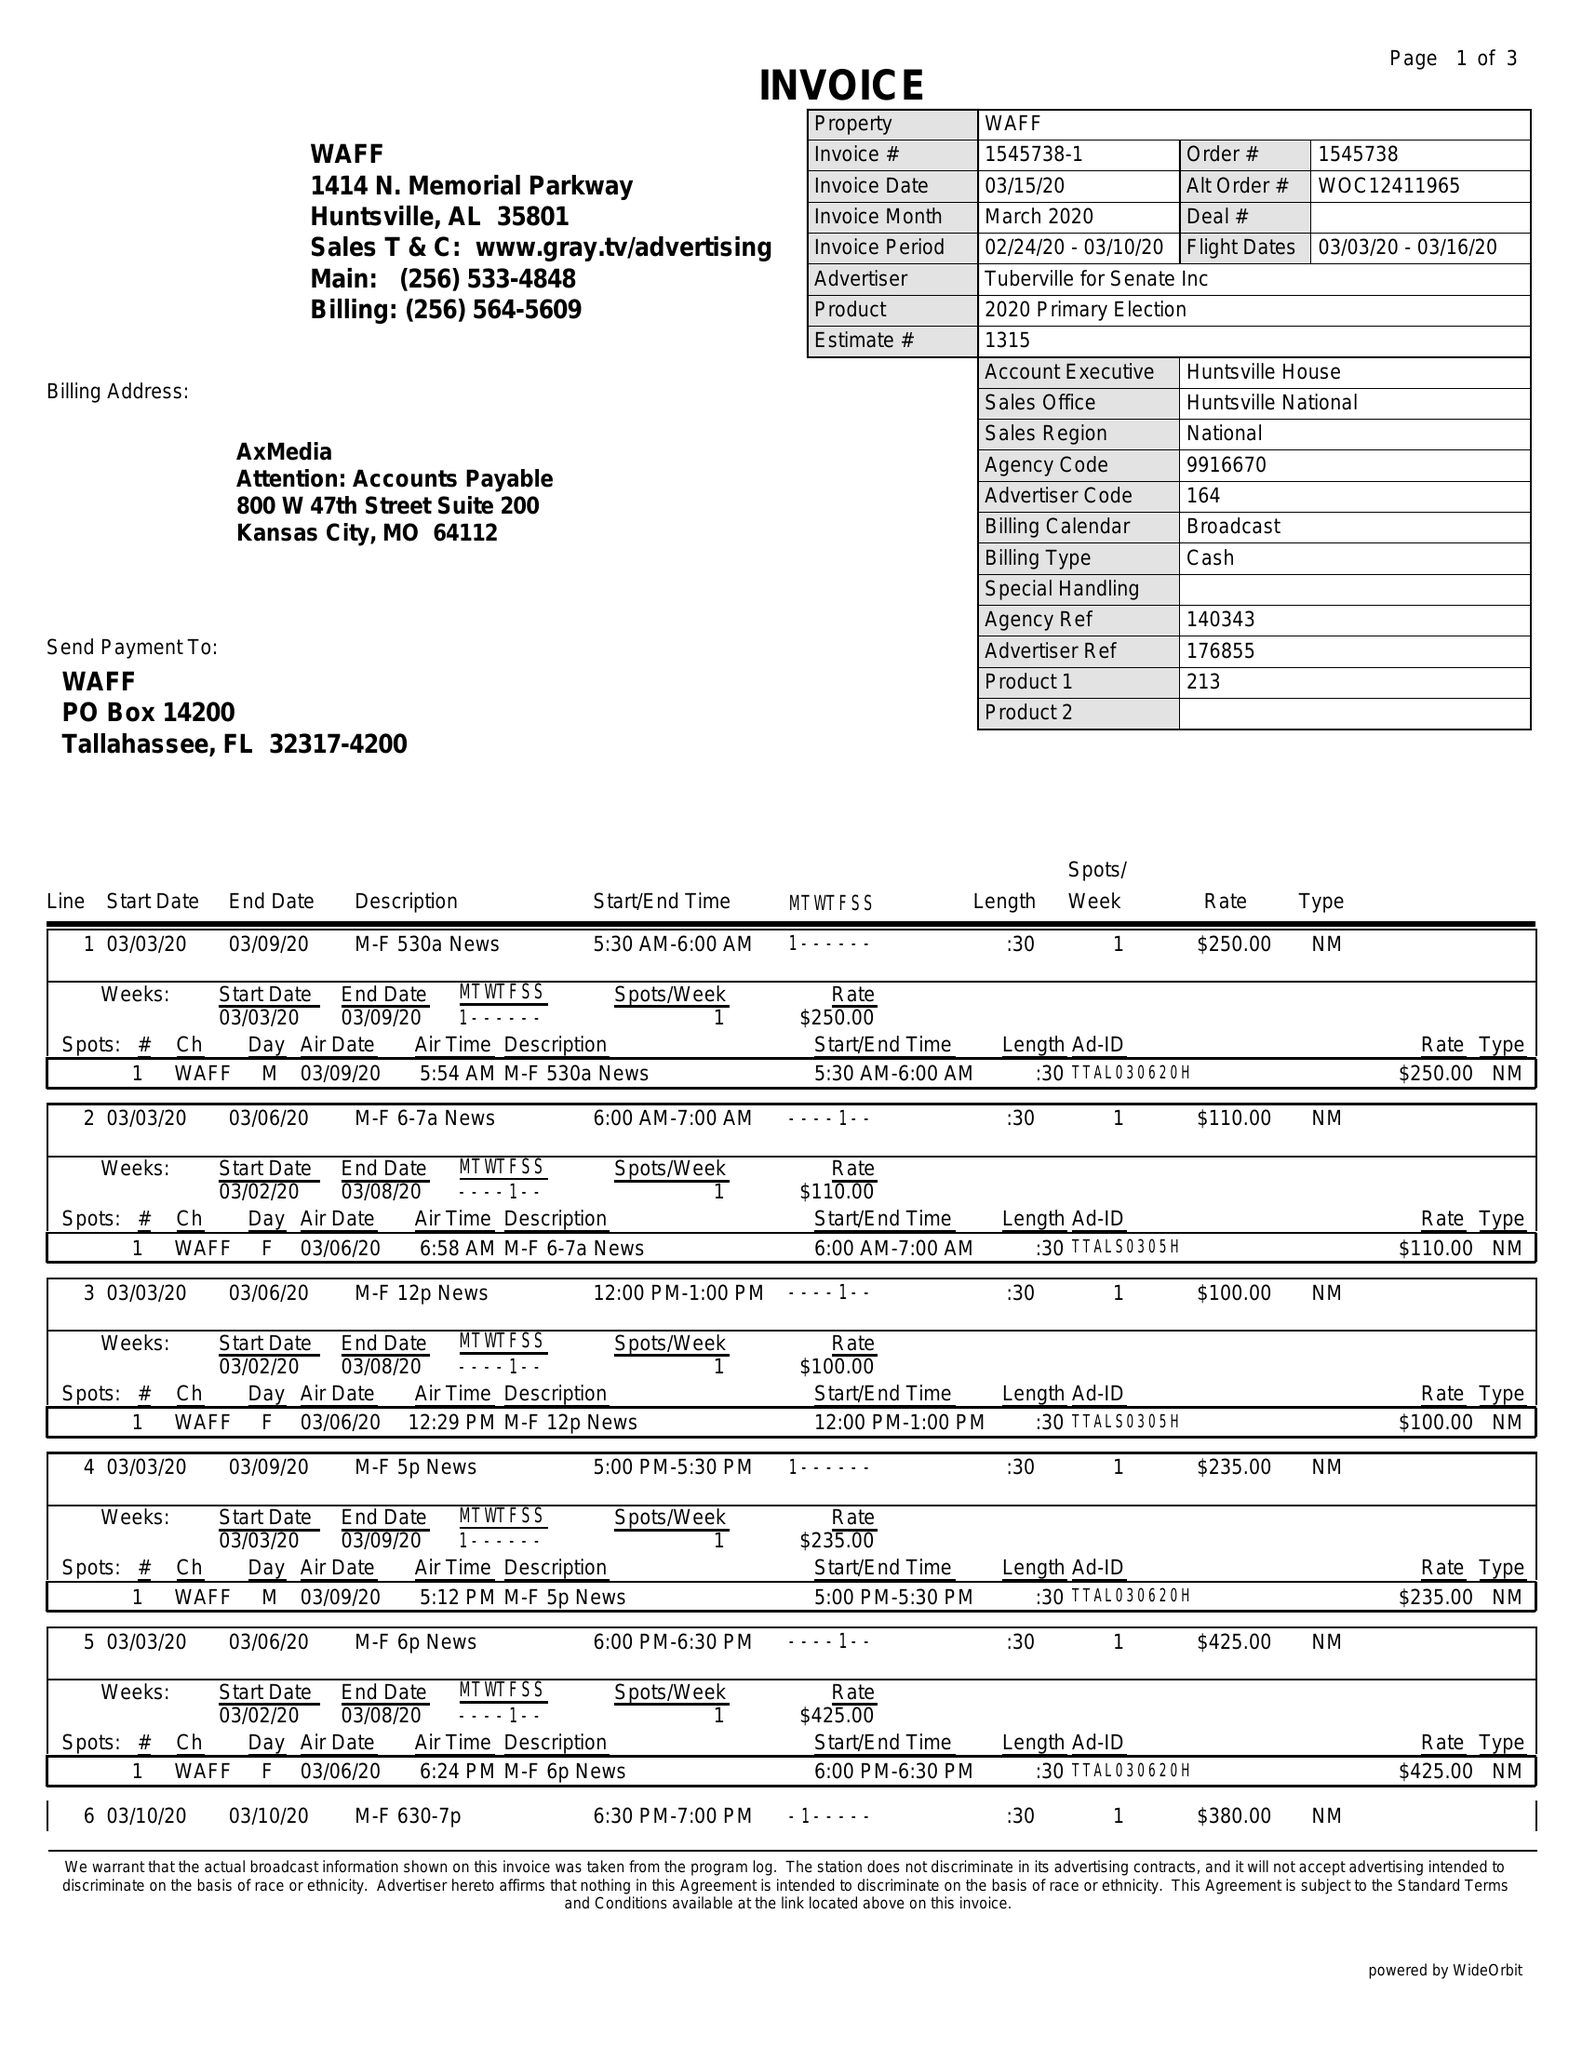What is the value for the gross_amount?
Answer the question using a single word or phrase. 3130.00 